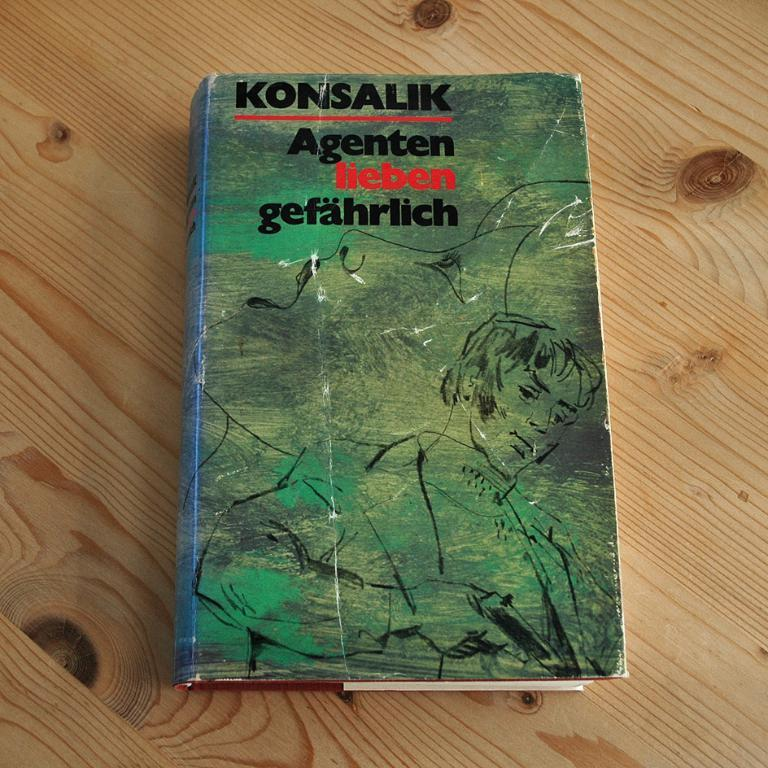<image>
Create a compact narrative representing the image presented. Konsalik Agenten lieben gefahrlich green and blue book 